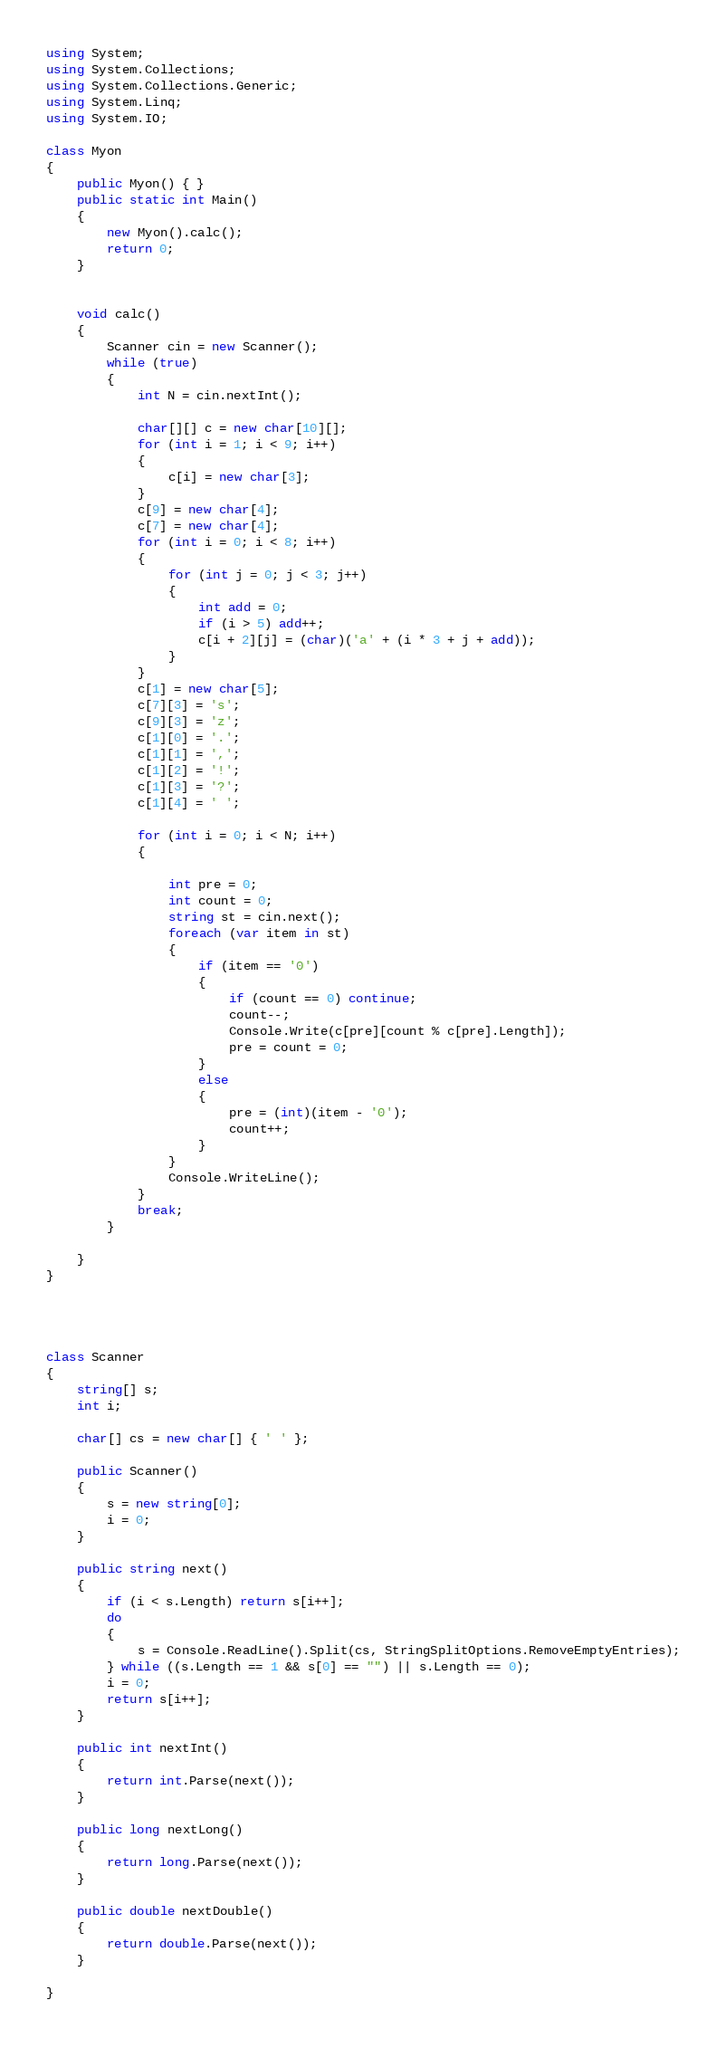<code> <loc_0><loc_0><loc_500><loc_500><_C#_>using System;
using System.Collections;
using System.Collections.Generic;
using System.Linq;
using System.IO;

class Myon
{
    public Myon() { }
    public static int Main()
    {
        new Myon().calc();
        return 0;
    }


    void calc()
    {
        Scanner cin = new Scanner();
        while (true)
        {
            int N = cin.nextInt();
            
            char[][] c = new char[10][];
            for (int i = 1; i < 9; i++)
            {
                c[i] = new char[3];
            }
            c[9] = new char[4];
            c[7] = new char[4];
            for (int i = 0; i < 8; i++)
            {
                for (int j = 0; j < 3; j++)
                {
                    int add = 0;
                    if (i > 5) add++;
                    c[i + 2][j] = (char)('a' + (i * 3 + j + add));
                }
            }
            c[1] = new char[5];
            c[7][3] = 's';
            c[9][3] = 'z';
            c[1][0] = '.';
            c[1][1] = ',';
            c[1][2] = '!';
            c[1][3] = '?';
            c[1][4] = ' ';

            for (int i = 0; i < N; i++)
            {

                int pre = 0;
                int count = 0;
                string st = cin.next();
                foreach (var item in st)
                {
                    if (item == '0')
                    {
                        if (count == 0) continue;
                        count--;
                        Console.Write(c[pre][count % c[pre].Length]);
                        pre = count = 0;
                    }
                    else
                    {
                        pre = (int)(item - '0');
                        count++;
                    }
                }
                Console.WriteLine();
            }
            break;
        }

    }
}




class Scanner
{
    string[] s;
    int i;

    char[] cs = new char[] { ' ' };

    public Scanner()
    {
        s = new string[0];
        i = 0;
    }

    public string next()
    {
        if (i < s.Length) return s[i++];
        do
        {
            s = Console.ReadLine().Split(cs, StringSplitOptions.RemoveEmptyEntries);
        } while ((s.Length == 1 && s[0] == "") || s.Length == 0);
        i = 0;
        return s[i++];
    }

    public int nextInt()
    {
        return int.Parse(next());
    }

    public long nextLong()
    {
        return long.Parse(next());
    }

    public double nextDouble()
    {
        return double.Parse(next());
    }

}</code> 